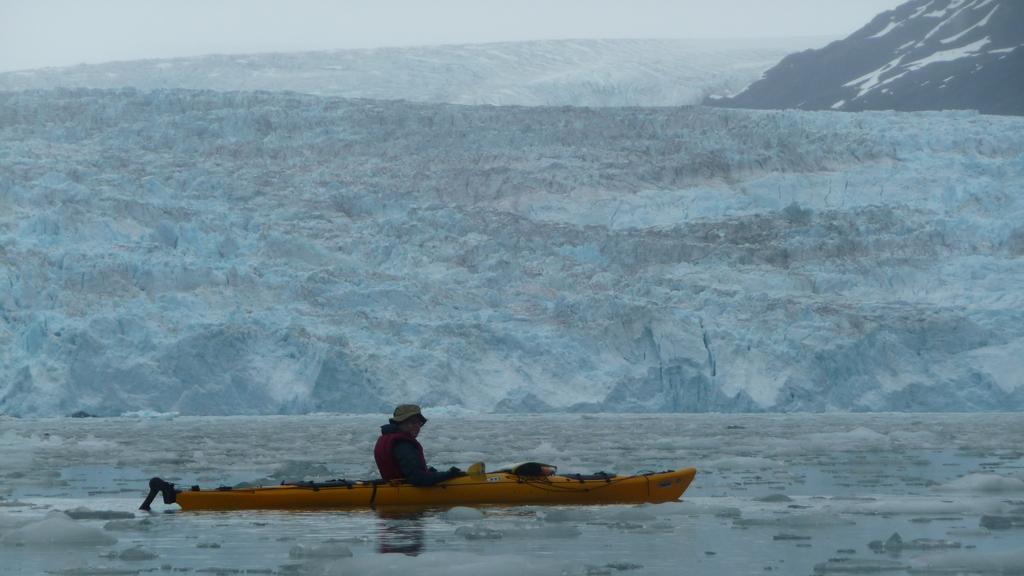Could you give a brief overview of what you see in this image? In this picture we can see a person in a boat and this boat is on the water and in the background we can see mountains, sky. 